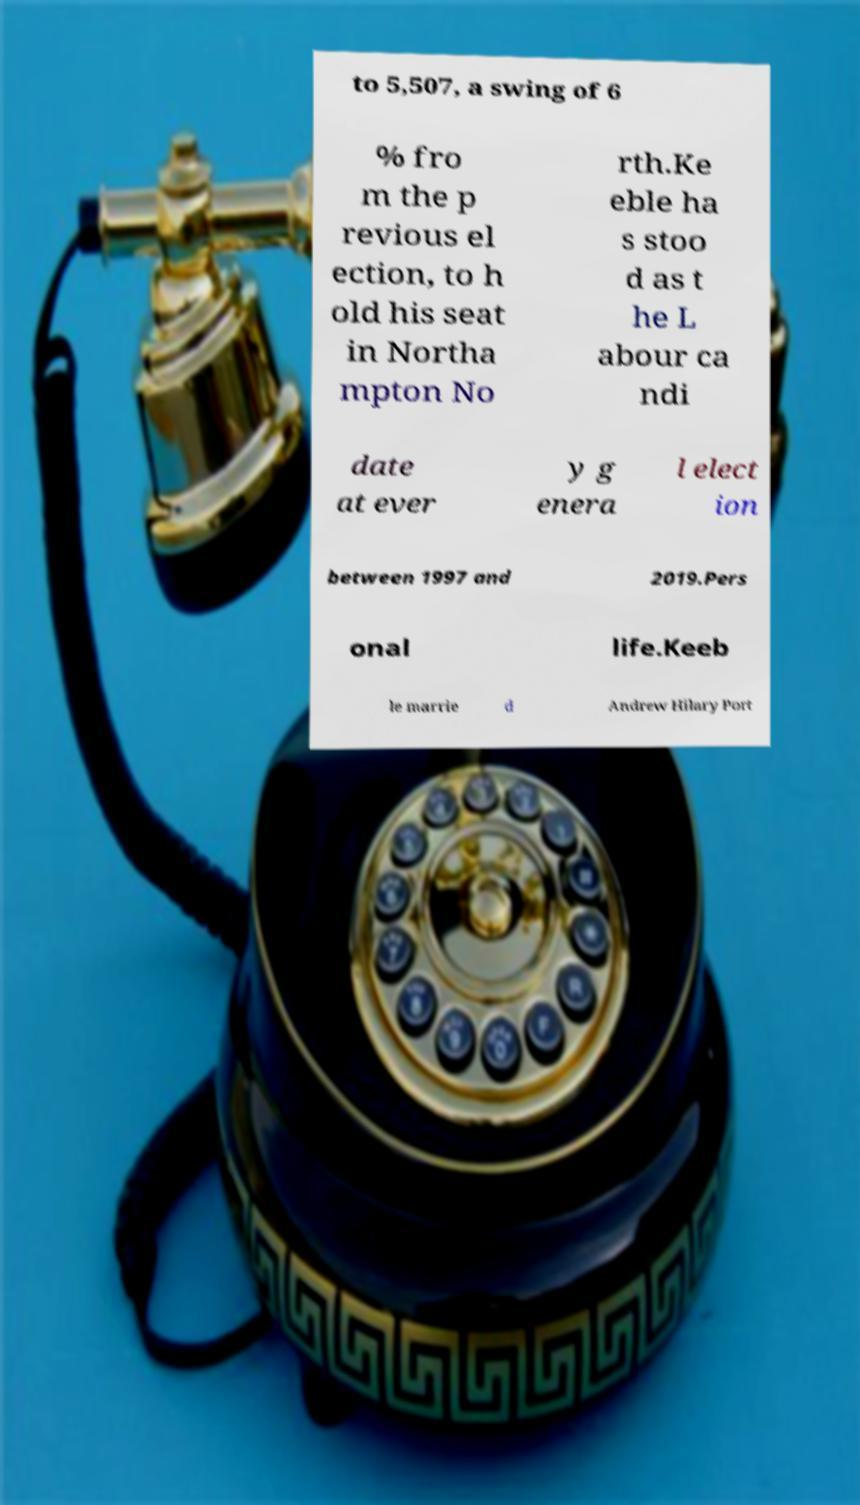Can you accurately transcribe the text from the provided image for me? to 5,507, a swing of 6 % fro m the p revious el ection, to h old his seat in Northa mpton No rth.Ke eble ha s stoo d as t he L abour ca ndi date at ever y g enera l elect ion between 1997 and 2019.Pers onal life.Keeb le marrie d Andrew Hilary Port 